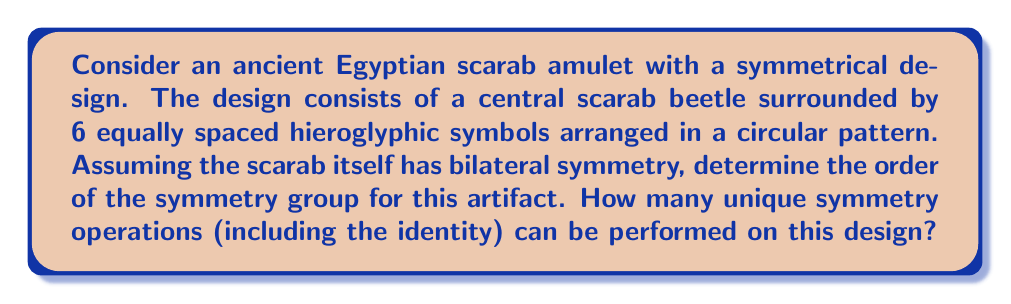Provide a solution to this math problem. To solve this problem, we need to consider the symmetries of the artifact:

1. Rotational symmetry:
   The artifact has 6 equally spaced symbols, suggesting 6-fold rotational symmetry. This means we can rotate the design by multiples of 60° (360°/6) to obtain identical configurations. There are 6 distinct rotations (including the identity rotation):
   $$R_0 = 0°, R_1 = 60°, R_2 = 120°, R_3 = 180°, R_4 = 240°, R_5 = 300°$$

2. Reflection symmetry:
   The bilateral symmetry of the scarab and the circular arrangement of symbols create 6 lines of reflection symmetry:
   - 3 lines passing through opposite symbols
   - 3 lines passing between adjacent symbols

3. Identity operation:
   The identity operation (doing nothing) is always included in a symmetry group.

To determine the order of the symmetry group, we count the total number of unique symmetry operations:
- 6 rotations (including identity)
- 6 reflections

Therefore, the total number of symmetry operations is:
$$6 + 6 = 12$$

This symmetry group is known as the dihedral group $D_6$, which has order 12.
Answer: The order of the symmetry group for the ancient Egyptian scarab amulet is 12. There are 12 unique symmetry operations that can be performed on this design, including the identity operation. 